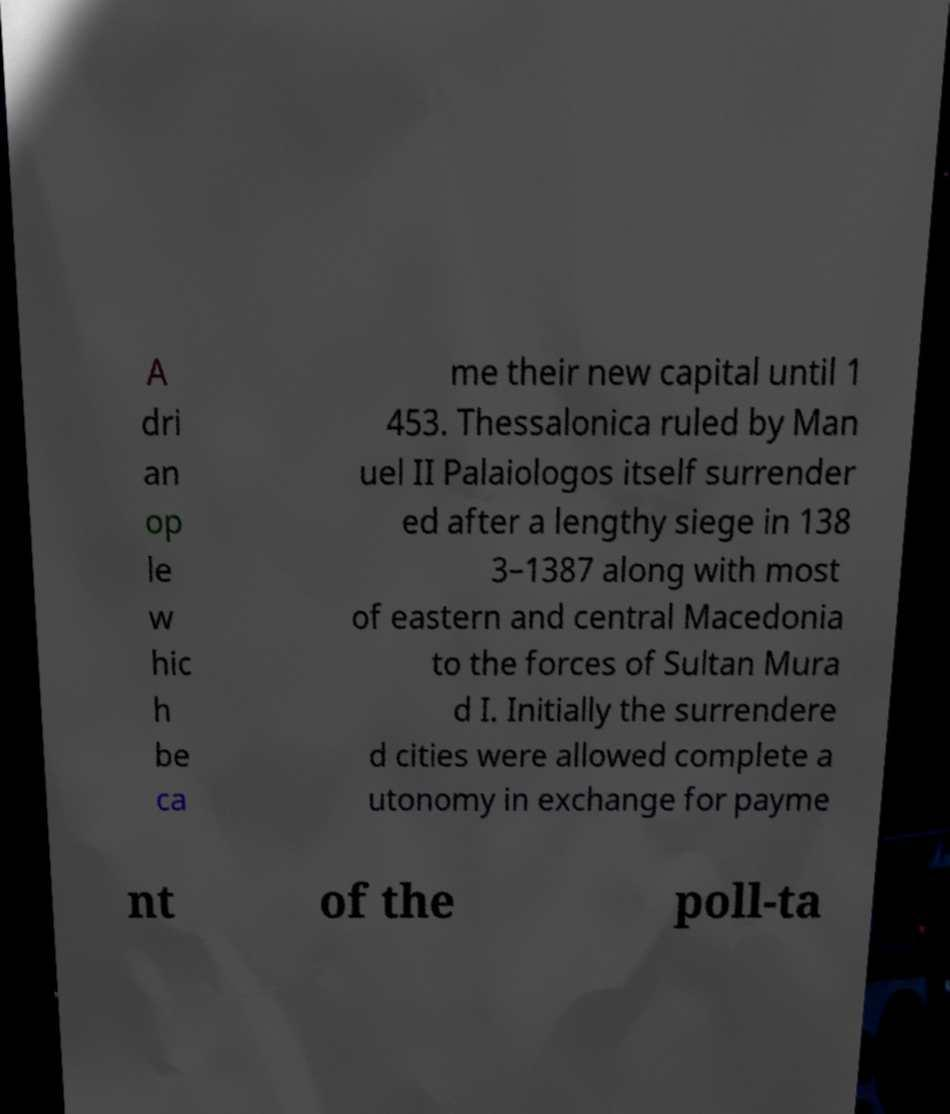Please read and relay the text visible in this image. What does it say? A dri an op le w hic h be ca me their new capital until 1 453. Thessalonica ruled by Man uel II Palaiologos itself surrender ed after a lengthy siege in 138 3–1387 along with most of eastern and central Macedonia to the forces of Sultan Mura d I. Initially the surrendere d cities were allowed complete a utonomy in exchange for payme nt of the poll-ta 